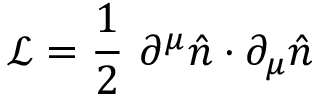<formula> <loc_0><loc_0><loc_500><loc_500>{ \mathcal { L } } = { \frac { 1 } { 2 } } \ \partial ^ { \mu } { \hat { n } } \cdot \partial _ { \mu } { \hat { n } }</formula> 